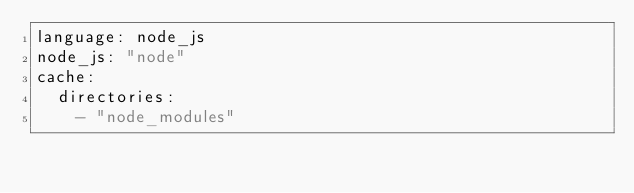Convert code to text. <code><loc_0><loc_0><loc_500><loc_500><_YAML_>language: node_js
node_js: "node"
cache:
  directories:
    - "node_modules"
</code> 